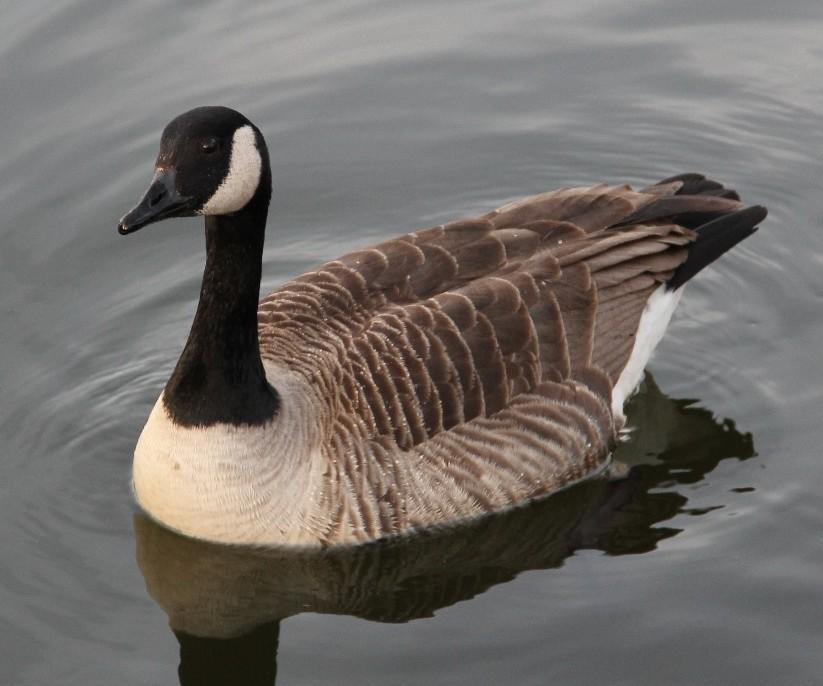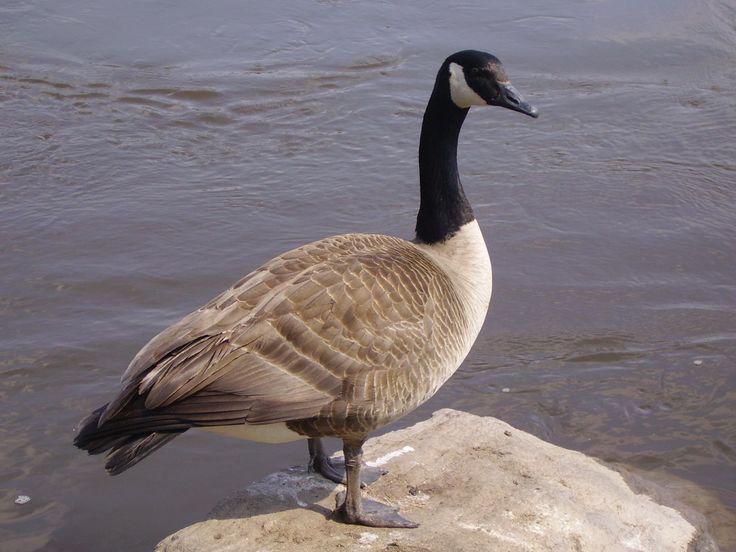The first image is the image on the left, the second image is the image on the right. Evaluate the accuracy of this statement regarding the images: "There are more than two birds total.". Is it true? Answer yes or no. No. 